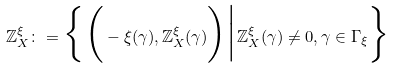<formula> <loc_0><loc_0><loc_500><loc_500>\mathbb { Z } ^ { \xi } _ { X } \colon = \Big \{ \Big ( - \xi ( \gamma ) , \mathbb { Z } _ { X } ^ { \xi } ( \gamma ) \Big ) \Big | \mathbb { Z } _ { X } ^ { \xi } ( \gamma ) \neq 0 , \gamma \in \Gamma _ { \xi } \Big \}</formula> 